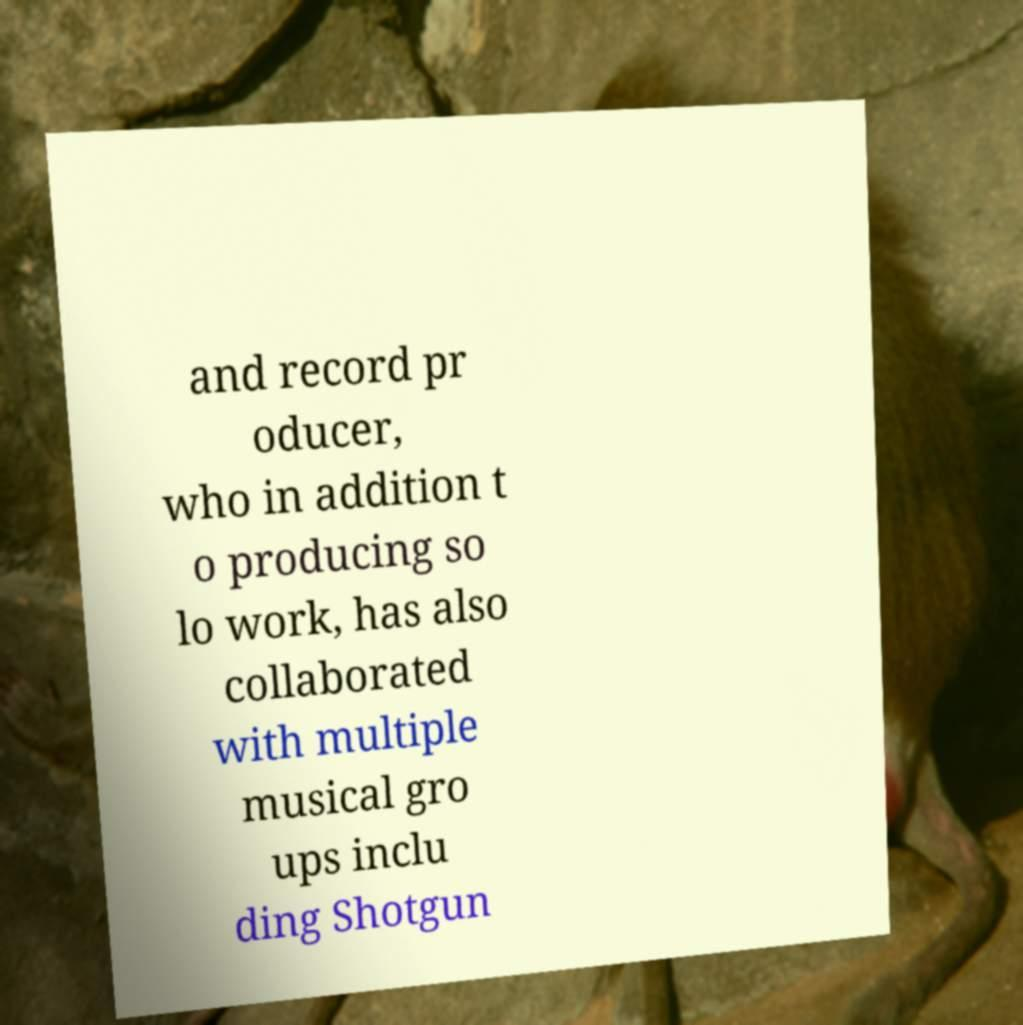Please read and relay the text visible in this image. What does it say? and record pr oducer, who in addition t o producing so lo work, has also collaborated with multiple musical gro ups inclu ding Shotgun 